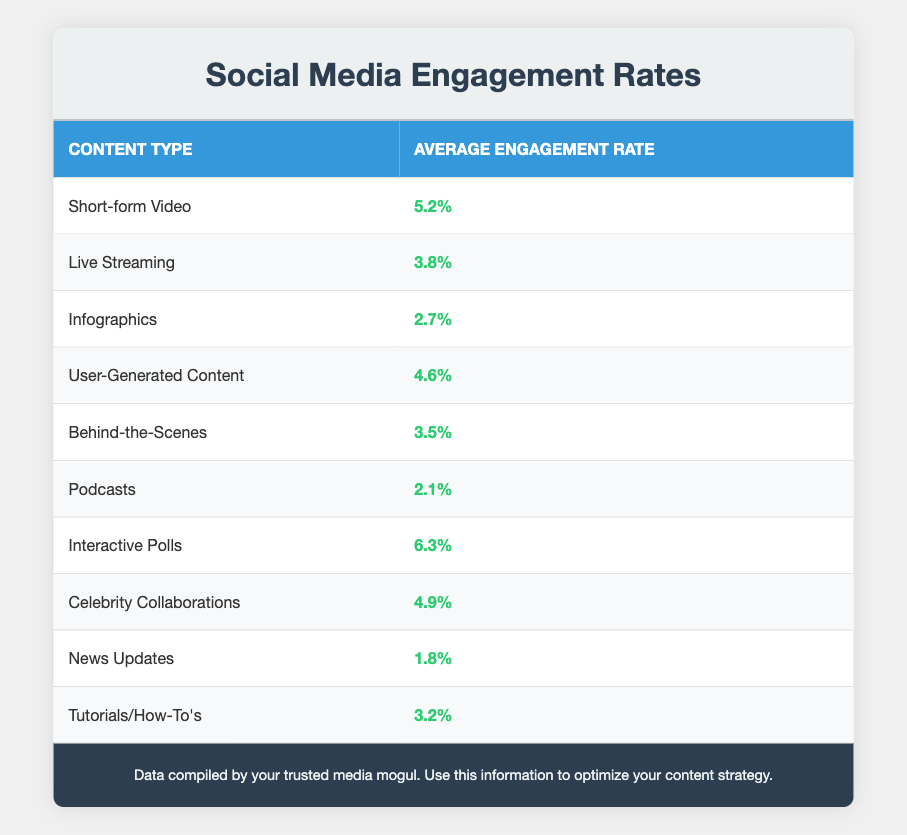What is the average engagement rate for short-form videos? The table directly provides the average engagement rate for short-form videos, which is listed in the "Average Engagement Rate" column. The engagement rate is 5.2%
Answer: 5.2% What content type has the highest average engagement rate? By scanning the table, I can see that the content type "Interactive Polls" has the highest engagement rate, which is listed as 6.3%
Answer: Interactive Polls Is the engagement rate for user-generated content higher than that of podcasts? User-generated content has an engagement rate of 4.6%, while podcasts have a lower engagement rate of 2.1%. Thus, user-generated content has a higher rate
Answer: Yes What is the difference in engagement rates between live streaming and behind-the-scenes content? Live streaming has an engagement rate of 3.8% and behind-the-scenes content has an engagement rate of 3.5%. Calculating the difference: 3.8% - 3.5% equals 0.3%
Answer: 0.3% Which content types have an engagement rate above 4%? I will look through the table and see that the content types with rates above 4% are: Short-form Video (5.2%), User-Generated Content (4.6%), Interactive Polls (6.3%), and Celebrity Collaborations (4.9%)
Answer: Short-form Video, User-Generated Content, Interactive Polls, Celebrity Collaborations What is the average engagement rate of the content types that feature user involvement (like polls and user-generated content)? The relevant content types are User-Generated Content (4.6%) and Interactive Polls (6.3%). To find the average: (4.6% + 6.3%) / 2 = 5.45%
Answer: 5.45% Is it true that tutorials/how-to's have a lower engagement rate than news updates? Tutorials/How-To's have an engagement rate of 3.2%, while news updates have an even lower rate of 1.8%. Thus, tutorials/how-to's have a higher engagement rate
Answer: No Which content type has a lower engagement rate: infographics or tutorials/how-to's? Infographics have an engagement rate of 2.7% while tutorials/how-to's have a rate of 3.2%. Comparing the two makes it clear that infographics have a lower rate
Answer: Infographics 